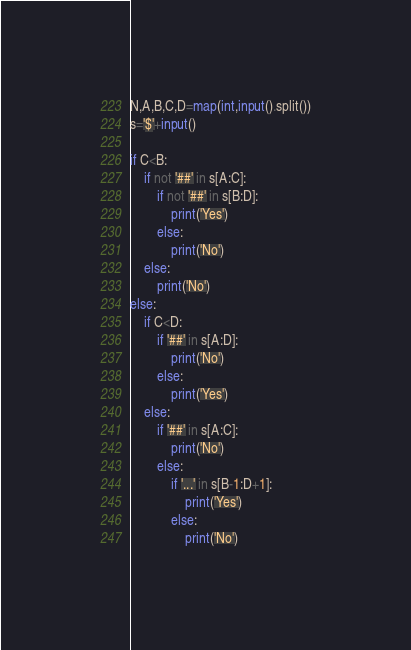<code> <loc_0><loc_0><loc_500><loc_500><_Python_>N,A,B,C,D=map(int,input().split())
s='$'+input()
 
if C<B:
    if not '##' in s[A:C]:
        if not '##' in s[B:D]:
            print('Yes')
        else:
            print('No')
    else:
        print('No')
else:
    if C<D:
        if '##' in s[A:D]:
            print('No')
        else:
            print('Yes')
    else:
        if '##' in s[A:C]:
            print('No')
        else:
            if '...' in s[B-1:D+1]:
                print('Yes')
            else:
                print('No')</code> 